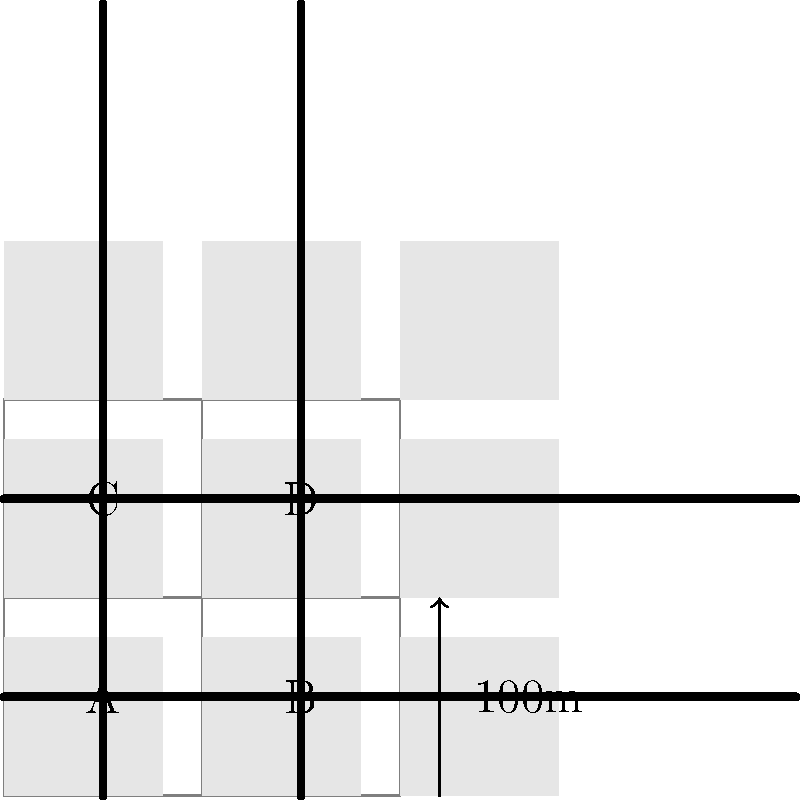In this reconstructed layout of an ancient city, which area (A, B, C, or D) is most likely to be the central marketplace based on its location and accessibility? To determine the most likely location of the central marketplace in this ancient city layout, we need to consider several factors:

1. Centrality: The marketplace should be centrally located for easy access from all parts of the city.
2. Accessibility: It should have good road connections from multiple directions.
3. Size: The area should be large enough to accommodate a marketplace.

Let's analyze each area:

A (Bottom-left): 
- Not centrally located
- Has road access from two directions
- Same size as other areas

B (Bottom-right):
- Not centrally located
- Has road access from two directions
- Same size as other areas

C (Top-left):
- More centrally located
- Has road access from three directions
- Same size as other areas

D (Top-right):
- More centrally located
- Has road access from three directions
- Same size as other areas

Areas C and D are both centrally located and have better accessibility compared to A and B. However, D is slightly more central and has better overall connectivity to all parts of the city.

Therefore, area D is the most likely location for the central marketplace based on its central position and superior accessibility.
Answer: D 